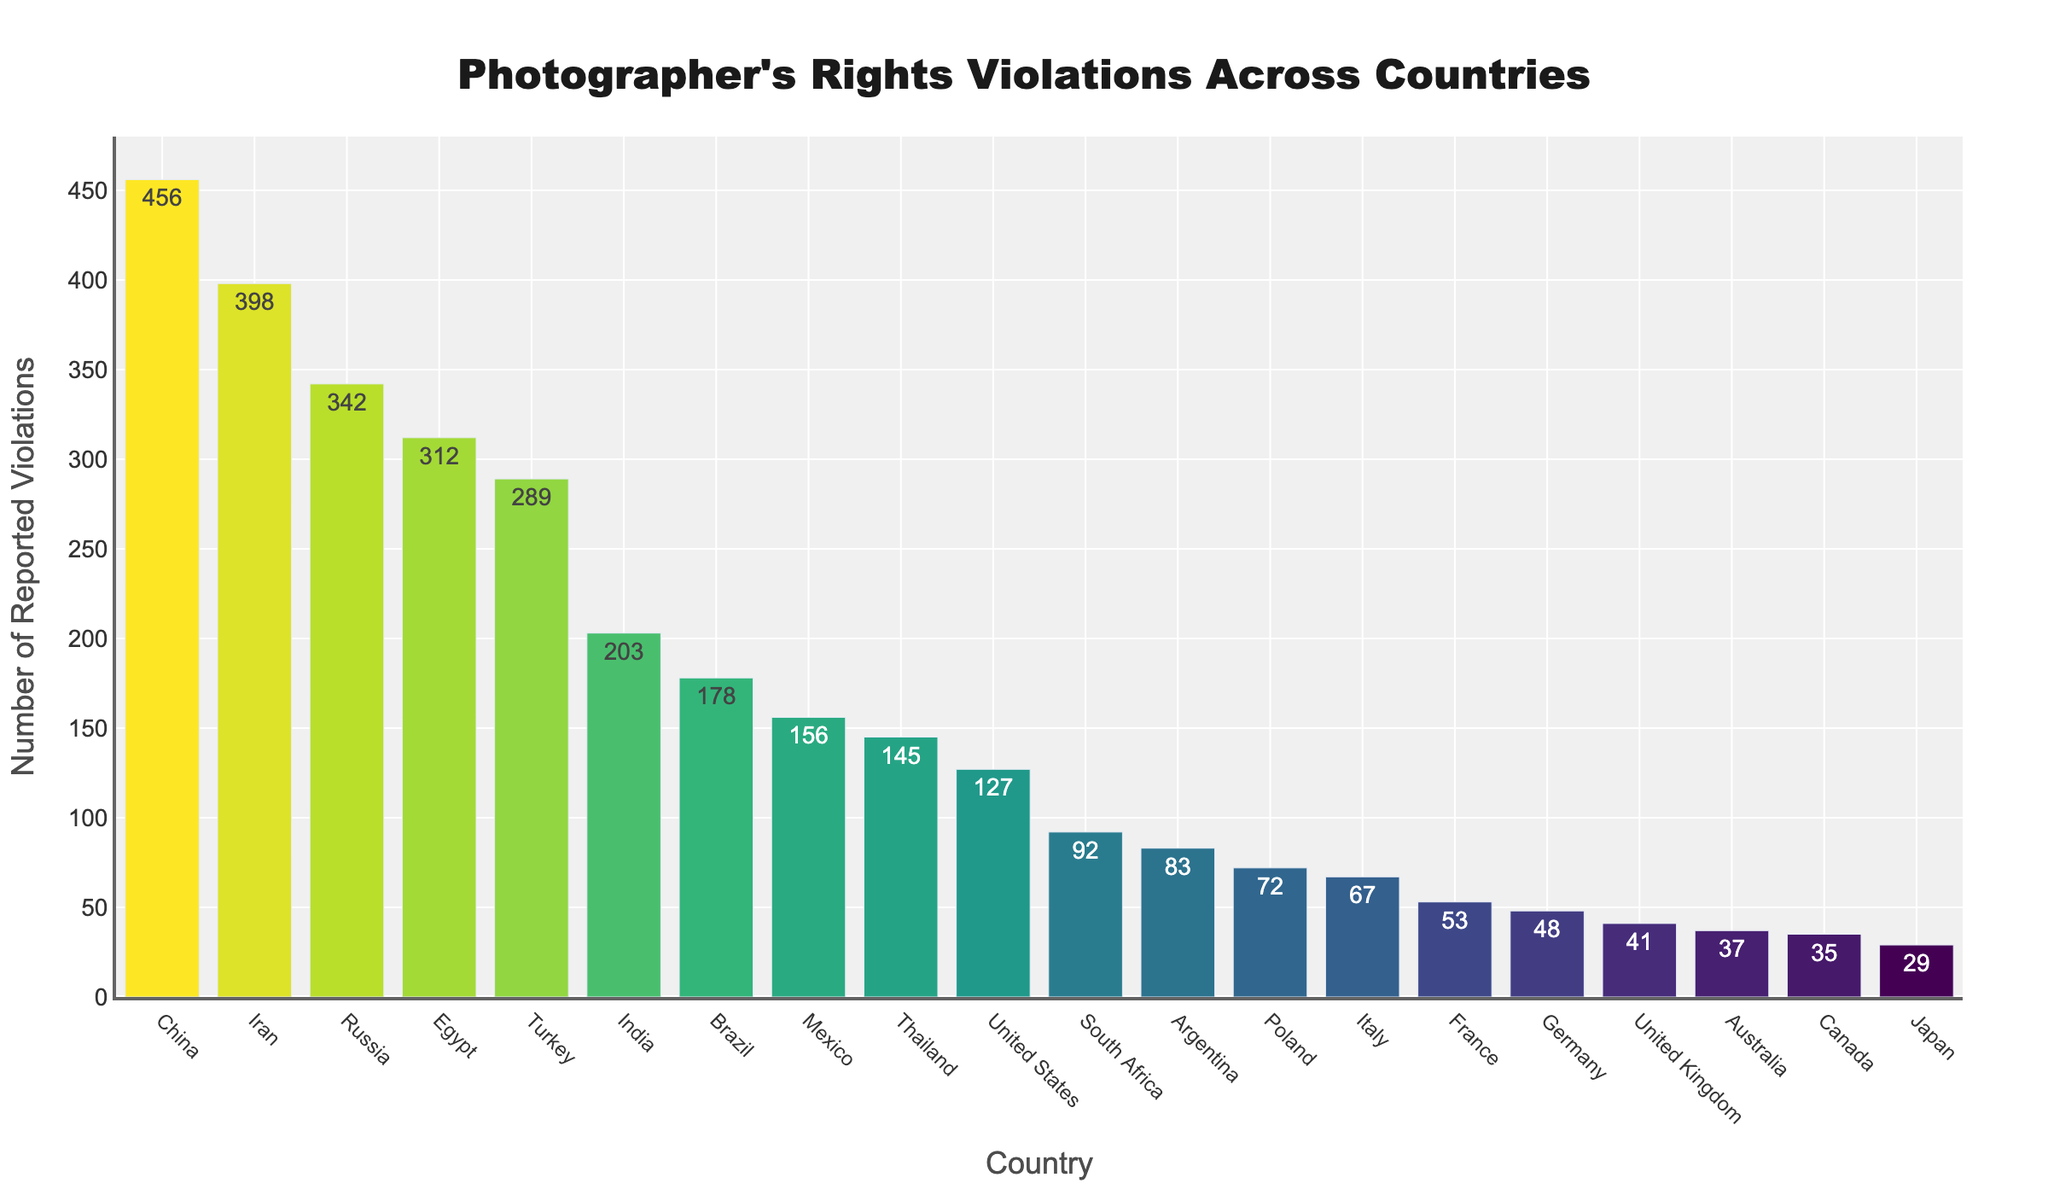Which country has the highest number of reported rights violations? Looking at the bar heights in the figure, we can see that China has the highest bar, indicating the highest number of reported rights violations.
Answer: China How does Brazil's number of reported rights violations compare to India's? Comparing the height of Brazil's bar to India's bar, we can see that India's bar is taller, indicating that India has more reported rights violations.
Answer: India has more violations than Brazil What is the total number of reported rights violations for the United States, Russia, and China combined? The number of reported violations for the United States is 127, for Russia is 342, and for China is 456. Summing these up, 127 + 342 + 456 = 925.
Answer: 925 What is the difference in reported rights violations between Iran and Turkey? Iran has 398 reported violations and Turkey has 289. The difference between them is 398 - 289 = 109.
Answer: 109 Which country has the fewest reported rights violations, and what is the count? The shortest bar corresponds to Japan, which indicates that Japan has the fewest reported rights violations. The count is 29.
Answer: Japan, 29 What is the average number of reported rights violations in the top five countries? The top five countries by number of reported rights violations are China (456), Russia (342), Iran (398), Egypt (312), and Turkey (289). To find the average, sum these values and divide by 5. (456 + 342 + 398 + 312 + 289) / 5 = 1797 / 5 = 359.4.
Answer: 359.4 Are there any countries with reported rights violations very close to 50? Observing the bar heights and the text labels in the figure, France has 53 reported violations, which is close to 50.
Answer: France How many more reported rights violations does Mexico have compared to Australia? Mexico has 156 reported violations and Australia has 37. The difference is 156 - 37 = 119.
Answer: 119 What is the collective number of reported rights violations in South America according to the figure (Brazil, Argentina)? Brazil has 178 and Argentina has 83 reported violations. Summing these up, 178 + 83 = 261.
Answer: 261 Which country in Europe has the highest number of reported rights violations? Among the European countries listed (France, United Kingdom, Germany, Italy, Poland), the tallest bar belongs to France with 53 reported violations.
Answer: France 